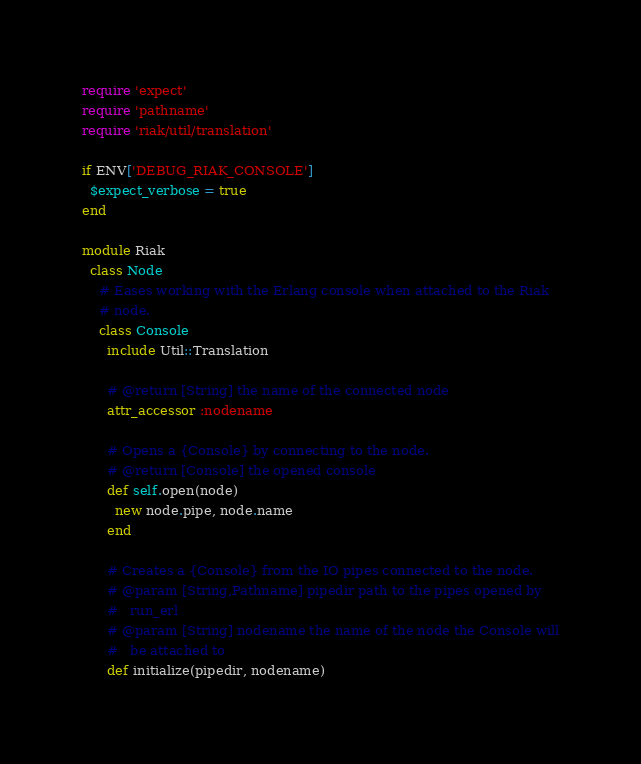<code> <loc_0><loc_0><loc_500><loc_500><_Ruby_>require 'expect'
require 'pathname'
require 'riak/util/translation'

if ENV['DEBUG_RIAK_CONSOLE']
  $expect_verbose = true
end

module Riak
  class Node
    # Eases working with the Erlang console when attached to the Riak
    # node.
    class Console
      include Util::Translation

      # @return [String] the name of the connected node
      attr_accessor :nodename

      # Opens a {Console} by connecting to the node.
      # @return [Console] the opened console
      def self.open(node)
        new node.pipe, node.name
      end

      # Creates a {Console} from the IO pipes connected to the node.
      # @param [String,Pathname] pipedir path to the pipes opened by
      #   run_erl
      # @param [String] nodename the name of the node the Console will
      #   be attached to
      def initialize(pipedir, nodename)</code> 